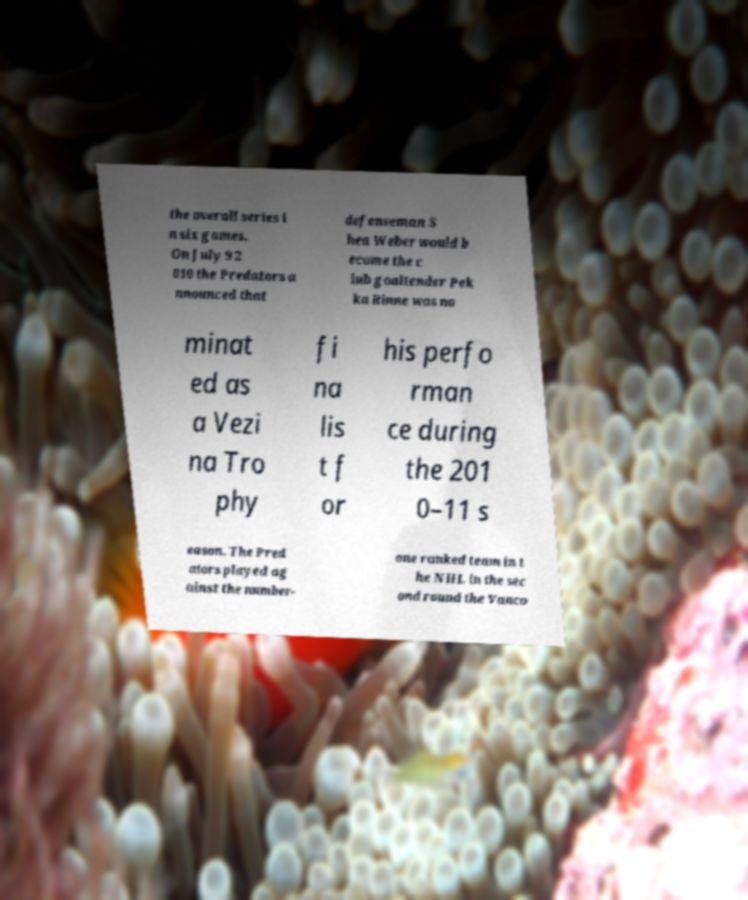Can you accurately transcribe the text from the provided image for me? the overall series i n six games. On July 9 2 010 the Predators a nnounced that defenseman S hea Weber would b ecome the c lub goaltender Pek ka Rinne was no minat ed as a Vezi na Tro phy fi na lis t f or his perfo rman ce during the 201 0–11 s eason. The Pred ators played ag ainst the number- one ranked team in t he NHL in the sec ond round the Vanco 